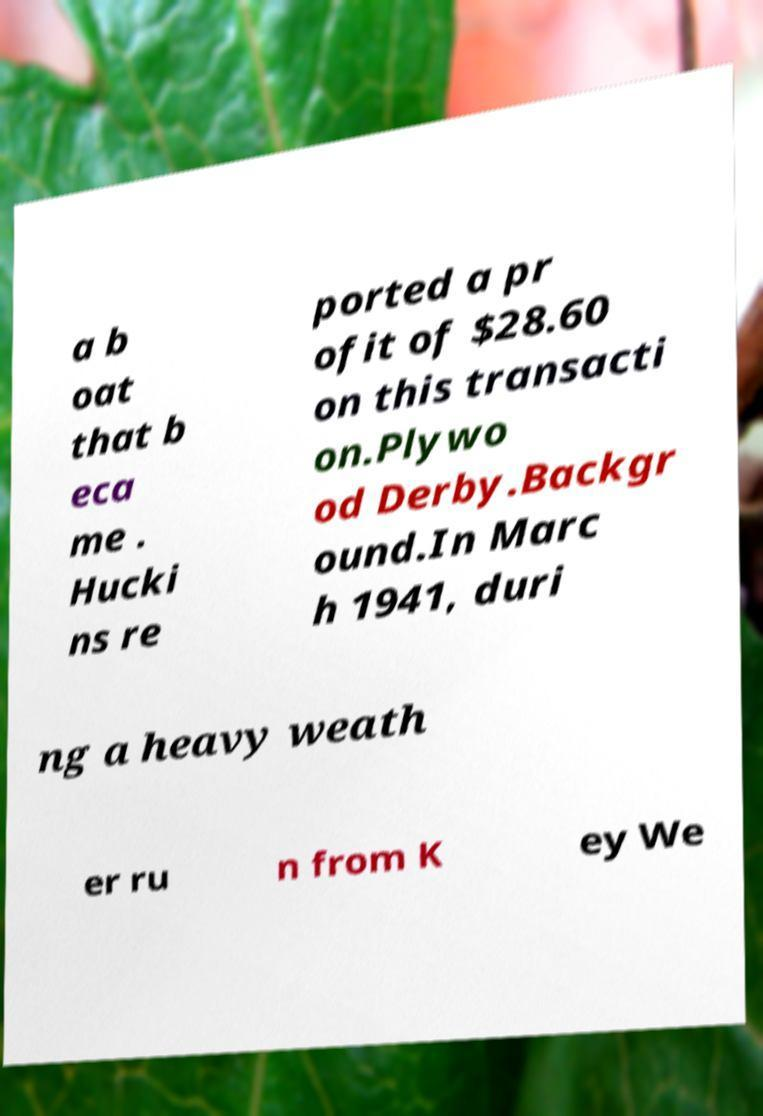There's text embedded in this image that I need extracted. Can you transcribe it verbatim? a b oat that b eca me . Hucki ns re ported a pr ofit of $28.60 on this transacti on.Plywo od Derby.Backgr ound.In Marc h 1941, duri ng a heavy weath er ru n from K ey We 